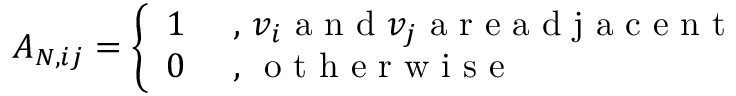<formula> <loc_0><loc_0><loc_500><loc_500>A _ { N , i j } = \left \{ \begin{array} { l l } { 1 } & { , v _ { i } a n d v _ { j } a r e a d j a c e n t } \\ { 0 } & { , o t h e r w i s e } \end{array}</formula> 